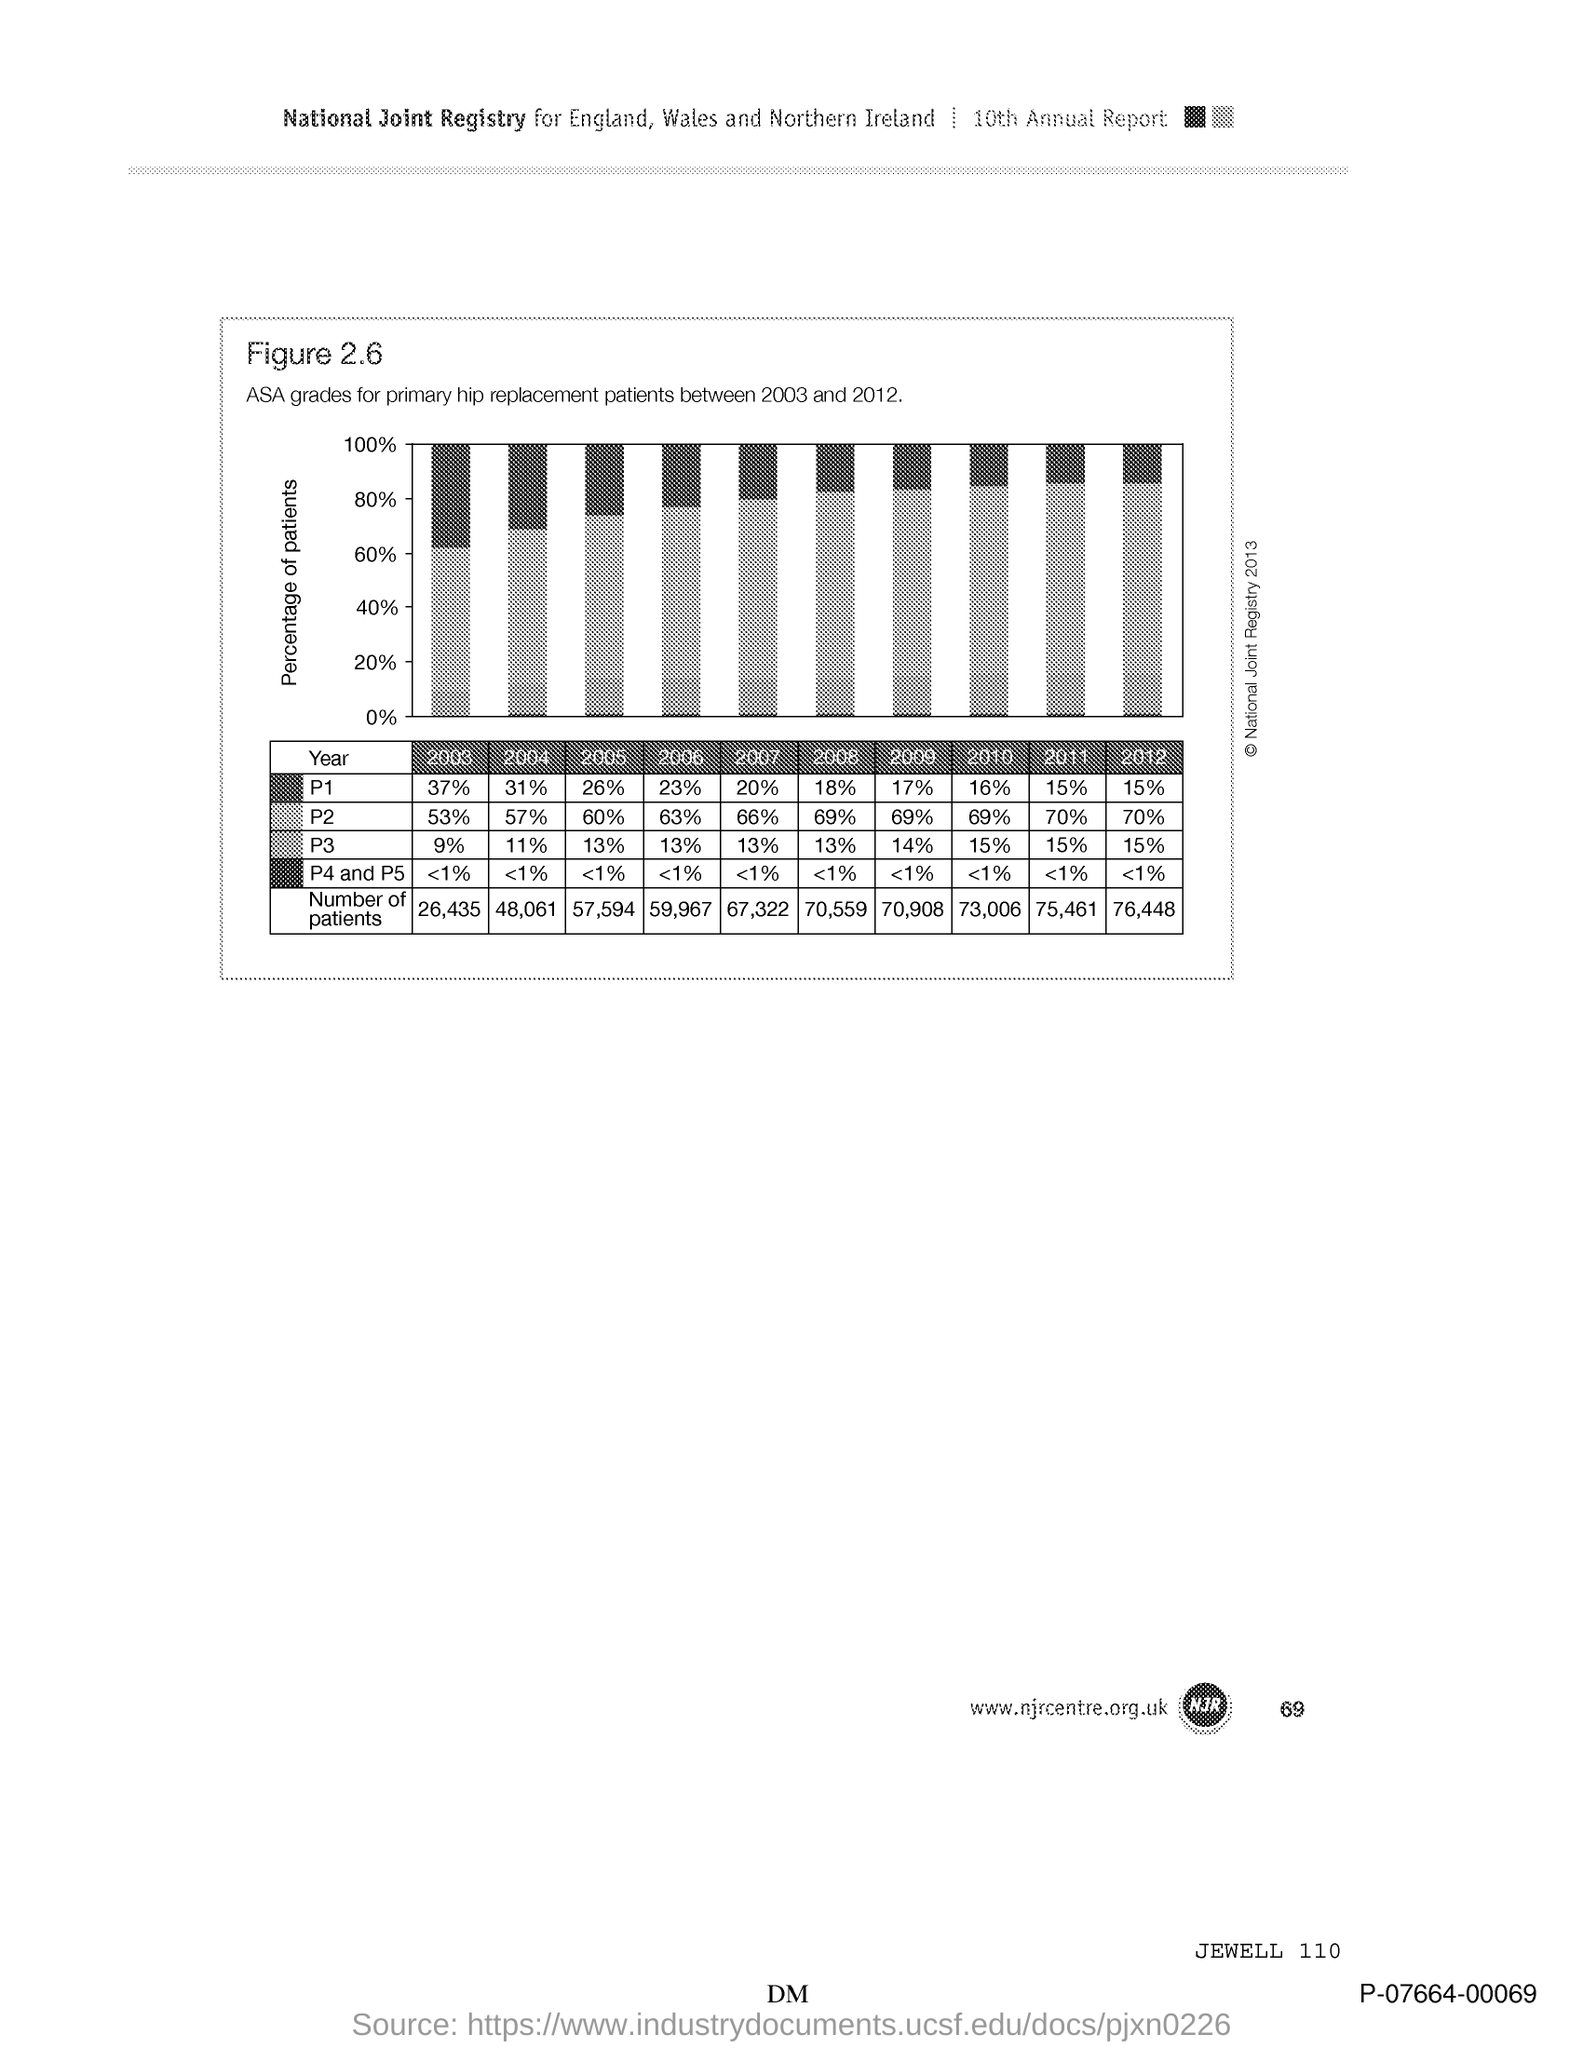Give some essential details in this illustration. Figure 2.6 shows the ASA grades for primary hip replacement patients between 2003 and 2012. The variable on the y-axis of the graph represents the percentage of patients. 